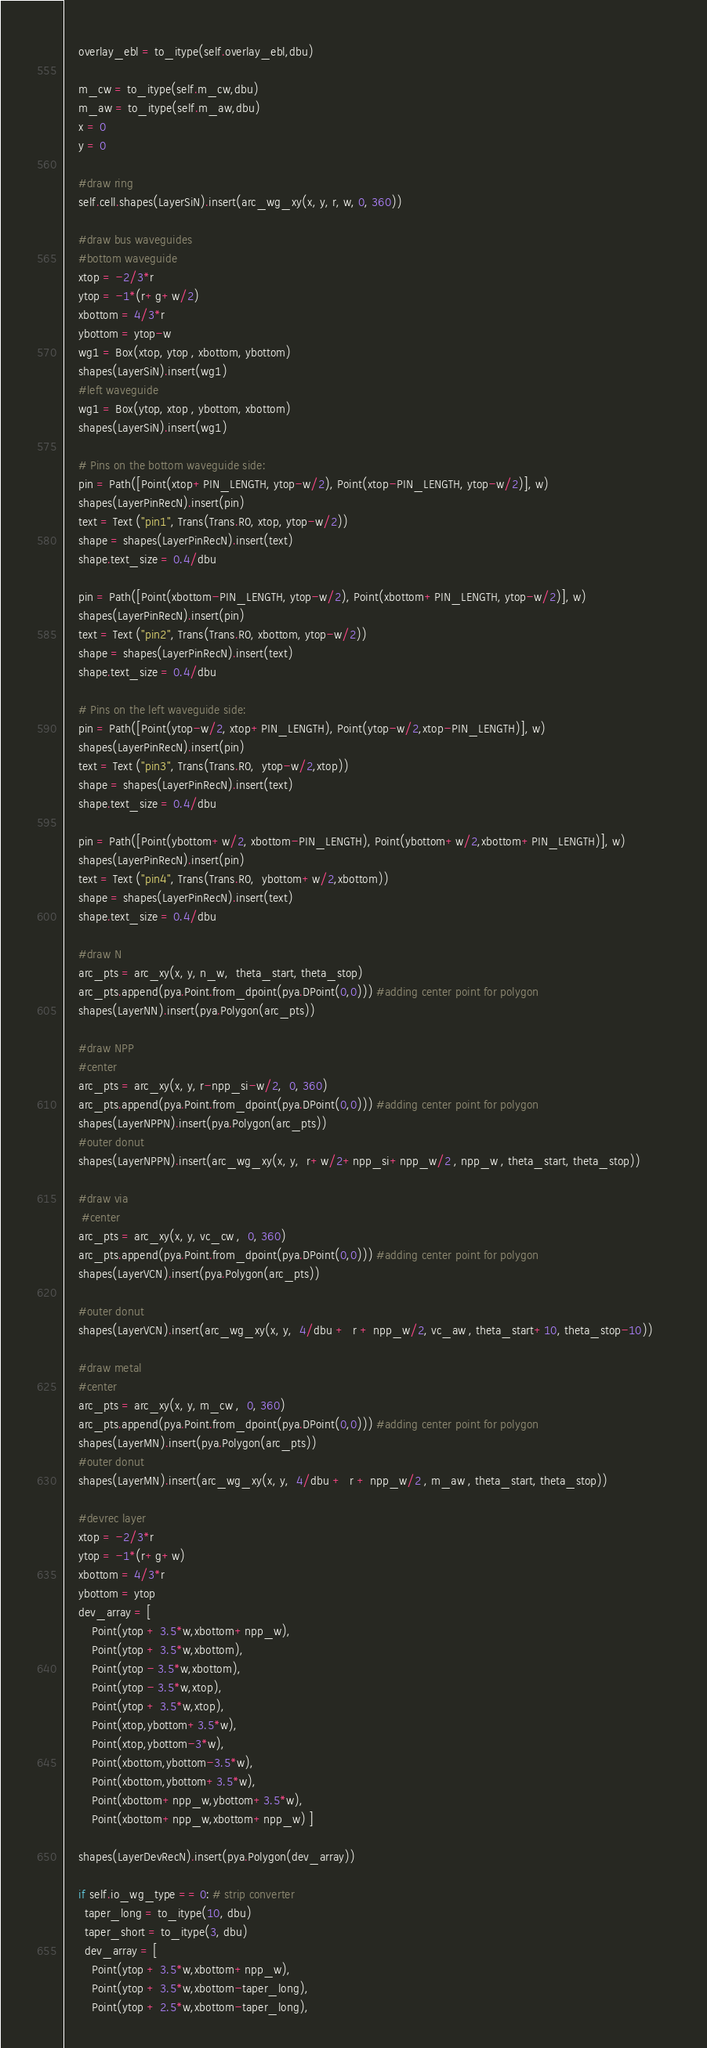<code> <loc_0><loc_0><loc_500><loc_500><_Python_>    overlay_ebl = to_itype(self.overlay_ebl,dbu)
    
    m_cw = to_itype(self.m_cw,dbu)
    m_aw = to_itype(self.m_aw,dbu)
    x = 0
    y = 0
    
    #draw ring
    self.cell.shapes(LayerSiN).insert(arc_wg_xy(x, y, r, w, 0, 360))
        
    #draw bus waveguides  
    #bottom waveguide
    xtop = -2/3*r
    ytop = -1*(r+g+w/2)
    xbottom = 4/3*r
    ybottom = ytop-w
    wg1 = Box(xtop, ytop , xbottom, ybottom)
    shapes(LayerSiN).insert(wg1)
    #left waveguide
    wg1 = Box(ytop, xtop , ybottom, xbottom)
    shapes(LayerSiN).insert(wg1) 

    # Pins on the bottom waveguide side:    
    pin = Path([Point(xtop+PIN_LENGTH, ytop-w/2), Point(xtop-PIN_LENGTH, ytop-w/2)], w)
    shapes(LayerPinRecN).insert(pin)
    text = Text ("pin1", Trans(Trans.R0, xtop, ytop-w/2))
    shape = shapes(LayerPinRecN).insert(text)
    shape.text_size = 0.4/dbu      

    pin = Path([Point(xbottom-PIN_LENGTH, ytop-w/2), Point(xbottom+PIN_LENGTH, ytop-w/2)], w)
    shapes(LayerPinRecN).insert(pin)
    text = Text ("pin2", Trans(Trans.R0, xbottom, ytop-w/2))
    shape = shapes(LayerPinRecN).insert(text)
    shape.text_size = 0.4/dbu      
  
    # Pins on the left waveguide side:    
    pin = Path([Point(ytop-w/2, xtop+PIN_LENGTH), Point(ytop-w/2,xtop-PIN_LENGTH)], w)
    shapes(LayerPinRecN).insert(pin)
    text = Text ("pin3", Trans(Trans.R0,  ytop-w/2,xtop))
    shape = shapes(LayerPinRecN).insert(text)
    shape.text_size = 0.4/dbu      
    
    pin = Path([Point(ybottom+w/2, xbottom-PIN_LENGTH), Point(ybottom+w/2,xbottom+PIN_LENGTH)], w)
    shapes(LayerPinRecN).insert(pin)
    text = Text ("pin4", Trans(Trans.R0,  ybottom+w/2,xbottom))
    shape = shapes(LayerPinRecN).insert(text)
    shape.text_size = 0.4/dbu      

    #draw N
    arc_pts = arc_xy(x, y, n_w,  theta_start, theta_stop)
    arc_pts.append(pya.Point.from_dpoint(pya.DPoint(0,0))) #adding center point for polygon
    shapes(LayerNN).insert(pya.Polygon(arc_pts)) 
    
    #draw NPP
    #center
    arc_pts = arc_xy(x, y, r-npp_si-w/2,  0, 360)
    arc_pts.append(pya.Point.from_dpoint(pya.DPoint(0,0))) #adding center point for polygon    
    shapes(LayerNPPN).insert(pya.Polygon(arc_pts)) 
    #outer donut
    shapes(LayerNPPN).insert(arc_wg_xy(x, y,  r+w/2+npp_si+npp_w/2 , npp_w , theta_start, theta_stop))     

    #draw via
     #center
    arc_pts = arc_xy(x, y, vc_cw ,  0, 360)
    arc_pts.append(pya.Point.from_dpoint(pya.DPoint(0,0))) #adding center point for polygon        
    shapes(LayerVCN).insert(pya.Polygon(arc_pts))
     
    #outer donut
    shapes(LayerVCN).insert(arc_wg_xy(x, y,  4/dbu +  r + npp_w/2, vc_aw , theta_start+10, theta_stop-10))     
    
    #draw metal
    #center
    arc_pts = arc_xy(x, y, m_cw ,  0, 360)
    arc_pts.append(pya.Point.from_dpoint(pya.DPoint(0,0))) #adding center point for polygon 
    shapes(LayerMN).insert(pya.Polygon(arc_pts)) 
    #outer donut
    shapes(LayerMN).insert(arc_wg_xy(x, y,  4/dbu +  r + npp_w/2 , m_aw , theta_start, theta_stop))     

    #devrec layer
    xtop = -2/3*r
    ytop = -1*(r+g+w)
    xbottom = 4/3*r
    ybottom = ytop
    dev_array = [
        Point(ytop + 3.5*w,xbottom+npp_w),
        Point(ytop + 3.5*w,xbottom),
        Point(ytop - 3.5*w,xbottom),
        Point(ytop - 3.5*w,xtop),
        Point(ytop + 3.5*w,xtop),
        Point(xtop,ybottom+3.5*w),
        Point(xtop,ybottom-3*w),
        Point(xbottom,ybottom-3.5*w),
        Point(xbottom,ybottom+3.5*w),
        Point(xbottom+npp_w,ybottom+3.5*w),
        Point(xbottom+npp_w,xbottom+npp_w) ]

    shapes(LayerDevRecN).insert(pya.Polygon(dev_array)) 

    if self.io_wg_type == 0: # strip converter
      taper_long = to_itype(10, dbu)
      taper_short = to_itype(3, dbu)
      dev_array = [
        Point(ytop + 3.5*w,xbottom+npp_w),
        Point(ytop + 3.5*w,xbottom-taper_long),
        Point(ytop + 2.5*w,xbottom-taper_long),</code> 